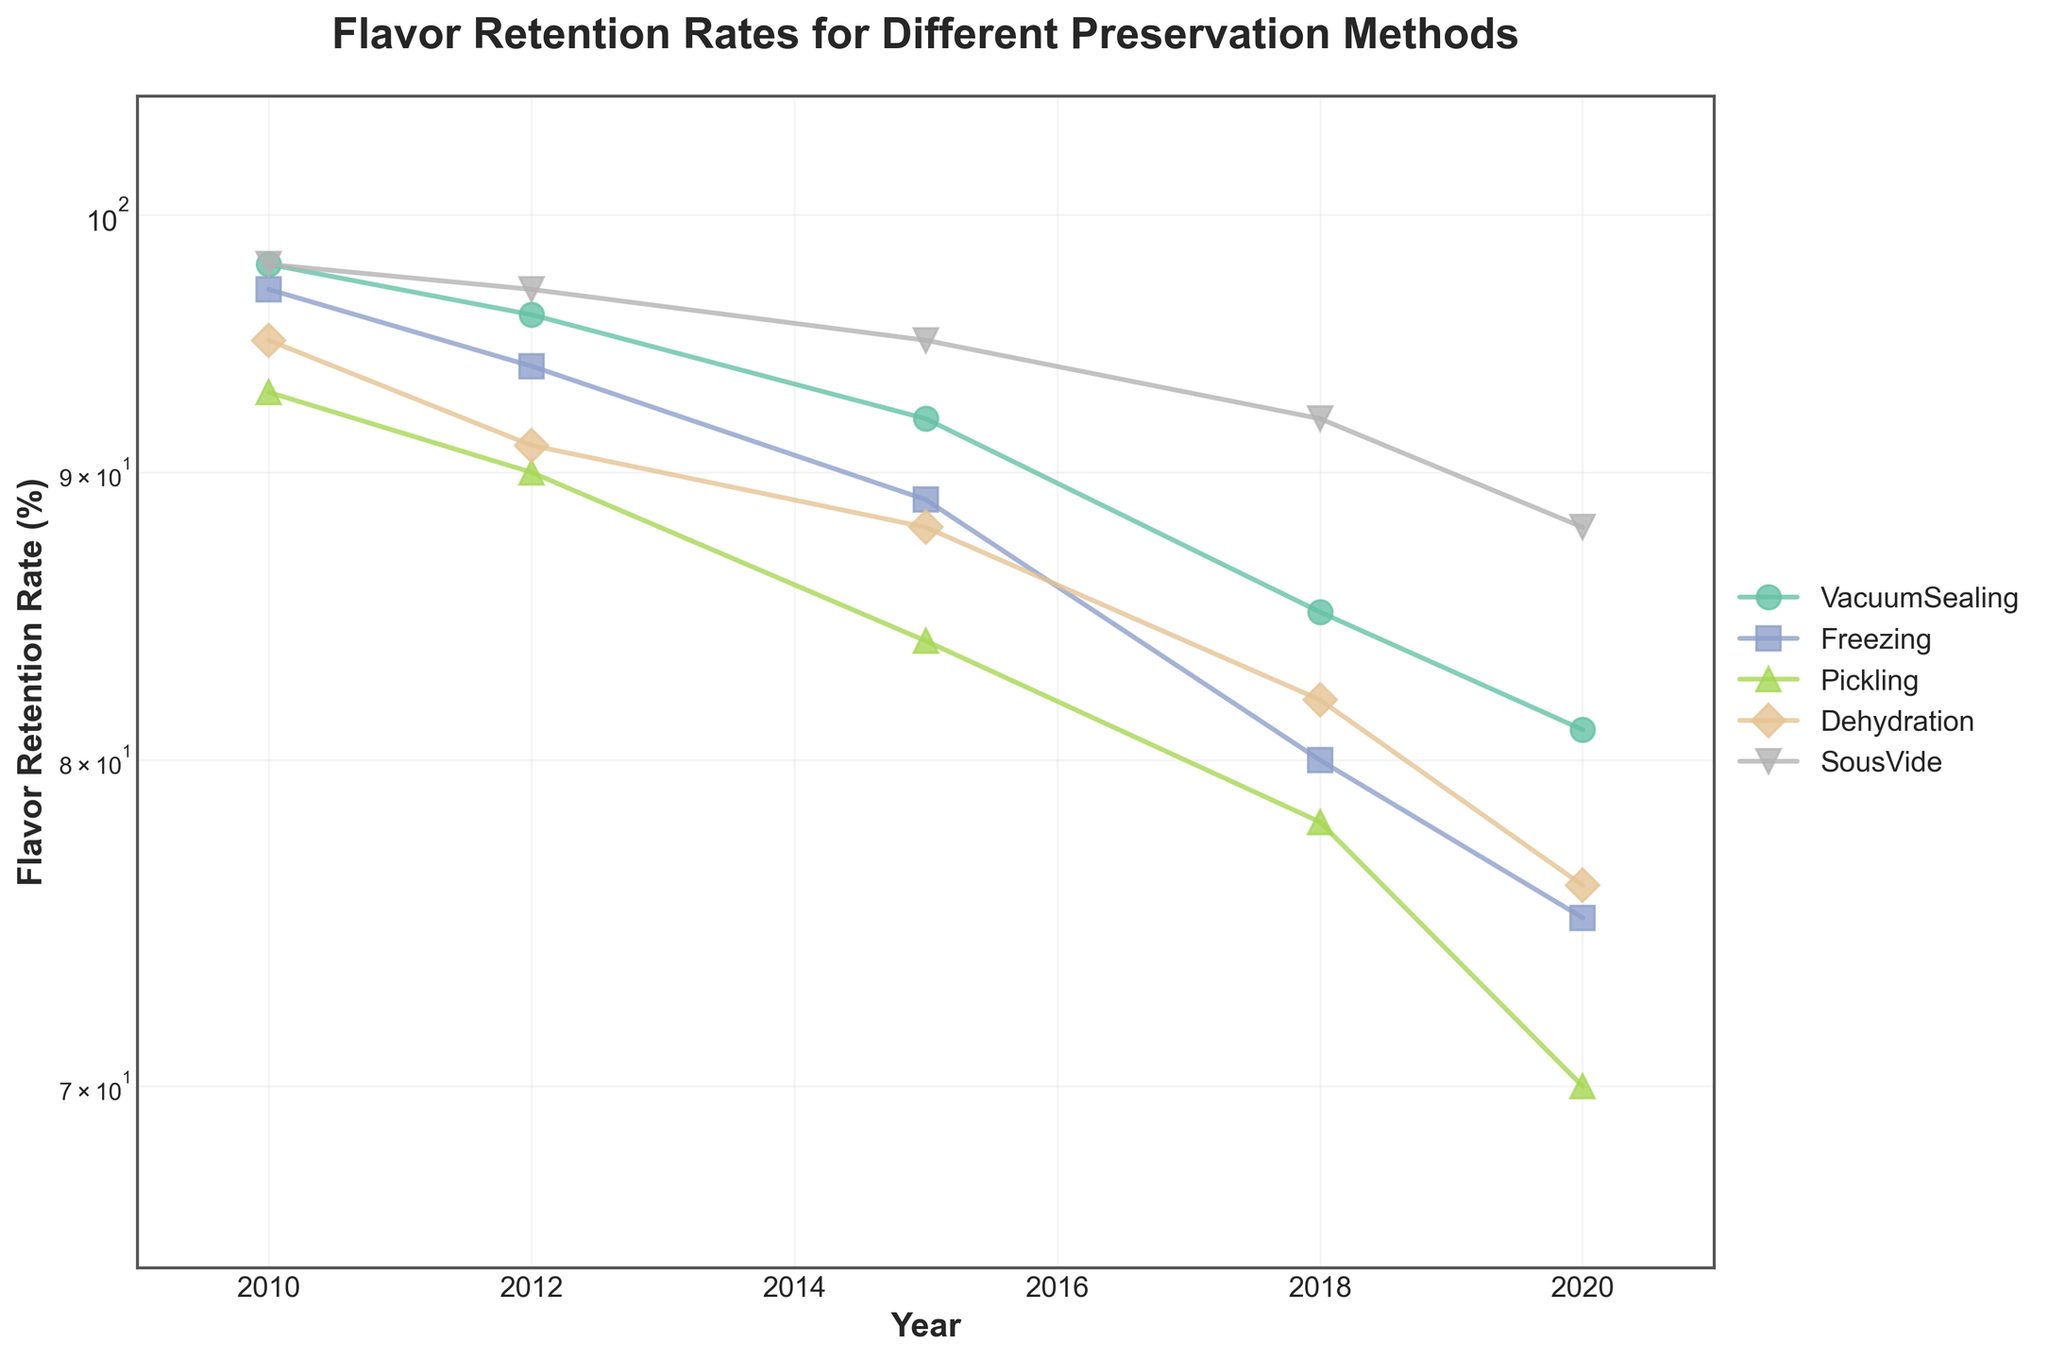What's the title of the figure? The title can be found at the top of the figure. It reads "Flavor Retention Rates for Different Preservation Methods".
Answer: Flavor Retention Rates for Different Preservation Methods What does the y-axis represent, and what is its scale? The y-axis represents the Flavor Retention Rate (%) and uses a logarithmic scale.
Answer: Flavor Retention Rate (%) with a log scale How many preservation methods are compared in the figure? Count the number of unique labels in the legend. There are five methods listed: VacuumSealing, Freezing, Pickling, Dehydration, and SousVide.
Answer: 5 Which preservation method maintains the highest flavor retention rate over time? Examine the lines to see which one stays the highest across all years. SousVide consistently has the highest flavor retention rate.
Answer: SousVide How does the flavor retention rate for VacuumSealing change from 2010 to 2020? Follow the line for VacuumSealing from 2010 to 2020. It starts at 98% in 2010 and drops to 81% in 2020.
Answer: It decreases from 98% to 81% Between which two years did Pickling experience the most significant drop in flavor retention rate? Compare the drops between consecutive years for Pickling: 2010-2012, 2012-2015, 2015-2018, 2018-2020. The biggest drop is from 2018 to 2020, where it goes from 78% to 70%.
Answer: 2018 to 2020 Which preservation method had a flavor retention rate below 80% first? Identify when each method first drops below 80%. Freezing drops below 80% by 2018.
Answer: Freezing By how many percentage points does the SousVide method outperform Freezing in 2020? Find the flavor retention rates for SousVide and Freezing in 2020 and subtract the two. SousVide is at 88%, and Freezing is at 75%, so the difference is 88% - 75%.
Answer: 13 percentage points Which method shows the least variability in flavor retention rate over the years? Look for the method whose line has the smallest range between its highest and lowest points. SousVide shows the least variability, ranging from 98% to 88%.
Answer: SousVide Which preservation method's flavor retention rate in 2015 is closest to 90%? Check the 2015 flavor retention rates for all methods: VacuumSealing (92%), Freezing (89%), Pickling (84%), Dehydration (88%), SousVide (95%). Freezing is the closest to 90% with 89%.
Answer: Freezing 